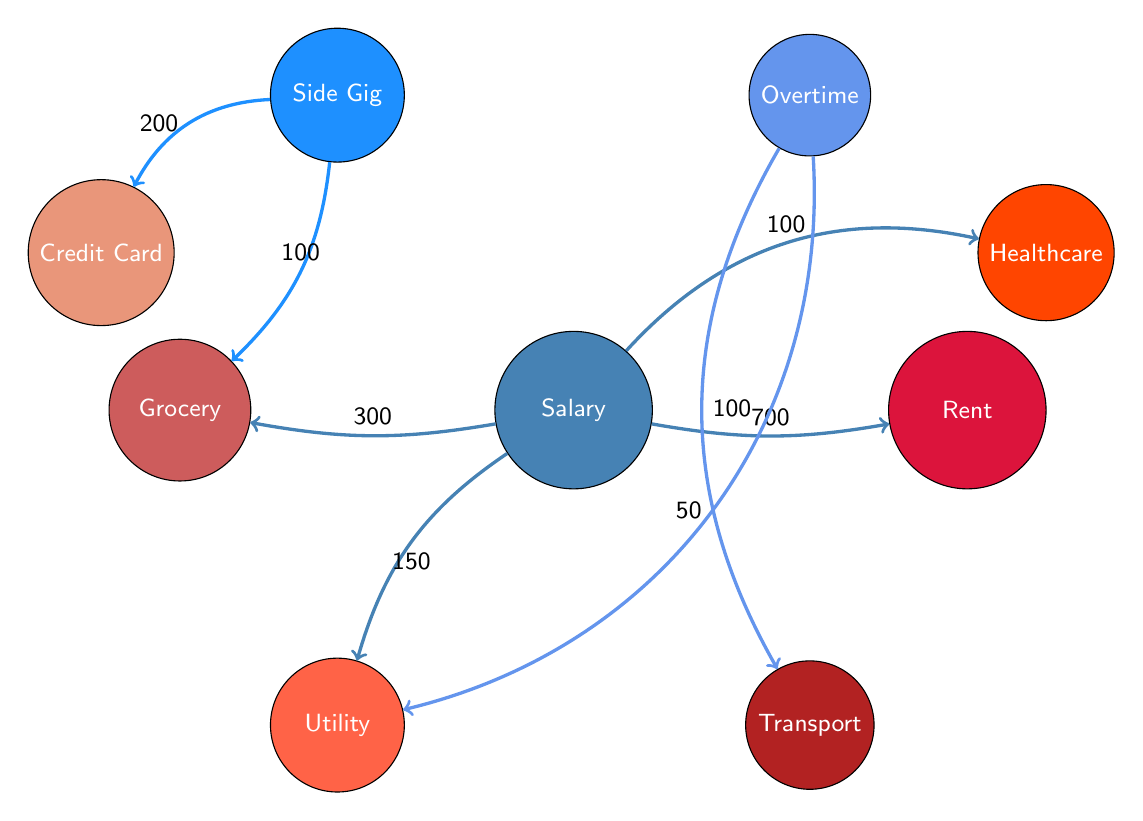What's the total amount linked to Rent? To find the total amount linked to Rent, we look for all connections leading to this node. The diagram shows a single link from "Salary from Full-Time Job" with a value of 700. Therefore, the total amount linked to Rent is 700.
Answer: 700 Which income source contributes to Grocery Expenses? The diagram shows that "Salary from Full-Time Job" contributes 300, and "Side Gig Income" contributes 100 to Grocery Expenses. Both sources are connected to this expense.
Answer: Salary from Full-Time Job and Side Gig Income What is the value associated with Utility Bills from Overtime Pay? The diagram indicates that there is an arrow from "Overtime Pay" to "Utility Bills" with a value of 50. Thus, the value associated with Utility Bills from Overtime Pay is 50.
Answer: 50 How many total nodes are there in the diagram? To determine the number of total nodes, we count each individual node in the diagram. There are eight nodes listed in the provided data, which include three income sources and five expenses.
Answer: 8 Which expense has the highest total contribution? By analyzing the connections, "Rent" has the highest contribution from "Salary from Full-Time Job" with a value of 700. Therefore, Rent is the expense with the highest total contribution.
Answer: Rent What is the total contribution of Side Gig Income to expenses? Observing the links, "Side Gig Income" contributes 200 to "Credit Card Payments" and 100 to "Grocery Expenses." Adding these together gives a total contribution of 200 + 100 = 300.
Answer: 300 How does Overtime Pay affect Transportation Costs? The diagram shows a direct connection from "Overtime Pay" to "Transportation Costs" with a value of 100. Therefore, Overtime Pay directly adds 100 to Transportation Costs.
Answer: 100 What is the total value of Healthcare Expenses from Salary? There is a connection from "Salary from Full-Time Job" to "Healthcare Expenses" with a value of 100. This is the only contributor to Healthcare Expenses shown in the diagram.
Answer: 100 